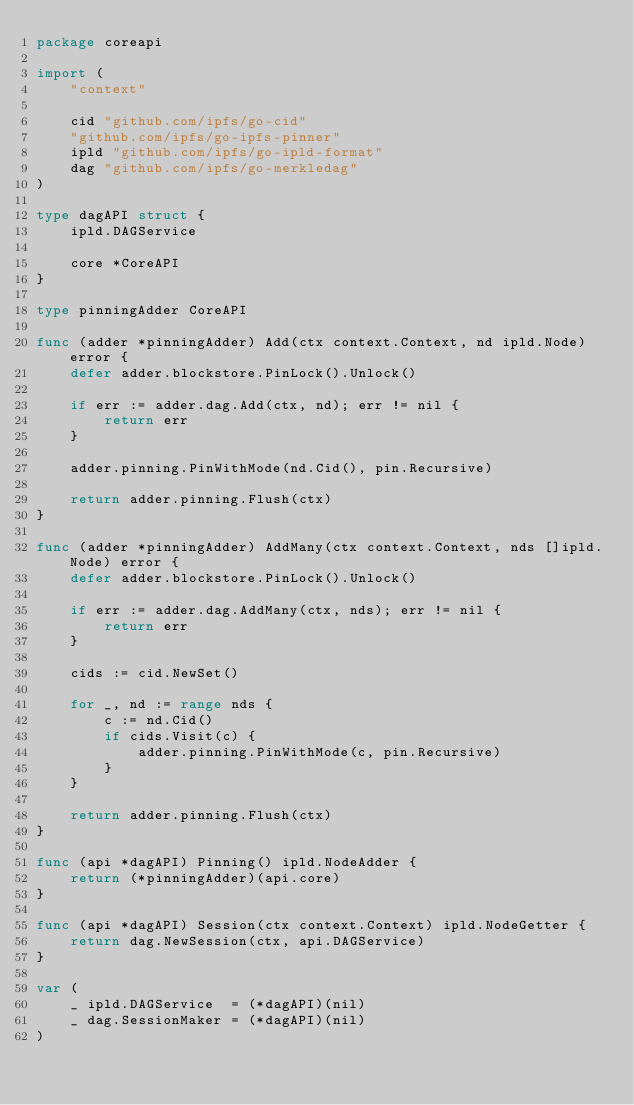Convert code to text. <code><loc_0><loc_0><loc_500><loc_500><_Go_>package coreapi

import (
	"context"

	cid "github.com/ipfs/go-cid"
	"github.com/ipfs/go-ipfs-pinner"
	ipld "github.com/ipfs/go-ipld-format"
	dag "github.com/ipfs/go-merkledag"
)

type dagAPI struct {
	ipld.DAGService

	core *CoreAPI
}

type pinningAdder CoreAPI

func (adder *pinningAdder) Add(ctx context.Context, nd ipld.Node) error {
	defer adder.blockstore.PinLock().Unlock()

	if err := adder.dag.Add(ctx, nd); err != nil {
		return err
	}

	adder.pinning.PinWithMode(nd.Cid(), pin.Recursive)

	return adder.pinning.Flush(ctx)
}

func (adder *pinningAdder) AddMany(ctx context.Context, nds []ipld.Node) error {
	defer adder.blockstore.PinLock().Unlock()

	if err := adder.dag.AddMany(ctx, nds); err != nil {
		return err
	}

	cids := cid.NewSet()

	for _, nd := range nds {
		c := nd.Cid()
		if cids.Visit(c) {
			adder.pinning.PinWithMode(c, pin.Recursive)
		}
	}

	return adder.pinning.Flush(ctx)
}

func (api *dagAPI) Pinning() ipld.NodeAdder {
	return (*pinningAdder)(api.core)
}

func (api *dagAPI) Session(ctx context.Context) ipld.NodeGetter {
	return dag.NewSession(ctx, api.DAGService)
}

var (
	_ ipld.DAGService  = (*dagAPI)(nil)
	_ dag.SessionMaker = (*dagAPI)(nil)
)
</code> 